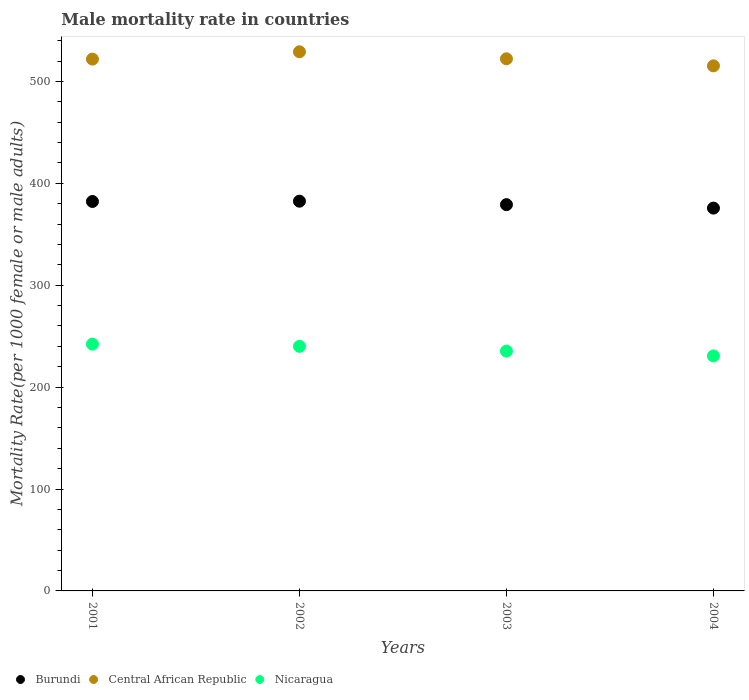What is the male mortality rate in Central African Republic in 2002?
Provide a succinct answer. 529.06. Across all years, what is the maximum male mortality rate in Central African Republic?
Provide a succinct answer. 529.06. Across all years, what is the minimum male mortality rate in Nicaragua?
Make the answer very short. 230.63. In which year was the male mortality rate in Central African Republic maximum?
Your response must be concise. 2002. What is the total male mortality rate in Burundi in the graph?
Offer a terse response. 1519.32. What is the difference between the male mortality rate in Burundi in 2002 and that in 2003?
Ensure brevity in your answer.  3.39. What is the difference between the male mortality rate in Burundi in 2004 and the male mortality rate in Central African Republic in 2001?
Offer a terse response. -146.2. What is the average male mortality rate in Burundi per year?
Your answer should be compact. 379.83. In the year 2001, what is the difference between the male mortality rate in Central African Republic and male mortality rate in Nicaragua?
Your response must be concise. 279.72. In how many years, is the male mortality rate in Central African Republic greater than 160?
Give a very brief answer. 4. What is the ratio of the male mortality rate in Central African Republic in 2001 to that in 2002?
Offer a terse response. 0.99. Is the male mortality rate in Central African Republic in 2002 less than that in 2003?
Make the answer very short. No. What is the difference between the highest and the second highest male mortality rate in Nicaragua?
Your response must be concise. 2.12. What is the difference between the highest and the lowest male mortality rate in Nicaragua?
Your response must be concise. 11.51. In how many years, is the male mortality rate in Burundi greater than the average male mortality rate in Burundi taken over all years?
Your answer should be compact. 2. Is the sum of the male mortality rate in Nicaragua in 2003 and 2004 greater than the maximum male mortality rate in Burundi across all years?
Your answer should be very brief. Yes. Is the male mortality rate in Central African Republic strictly greater than the male mortality rate in Burundi over the years?
Keep it short and to the point. Yes. Is the male mortality rate in Nicaragua strictly less than the male mortality rate in Burundi over the years?
Offer a very short reply. Yes. How many years are there in the graph?
Provide a short and direct response. 4. Does the graph contain grids?
Make the answer very short. No. What is the title of the graph?
Give a very brief answer. Male mortality rate in countries. Does "Senegal" appear as one of the legend labels in the graph?
Provide a succinct answer. No. What is the label or title of the Y-axis?
Provide a short and direct response. Mortality Rate(per 1000 female or male adults). What is the Mortality Rate(per 1000 female or male adults) of Burundi in 2001?
Provide a short and direct response. 382.16. What is the Mortality Rate(per 1000 female or male adults) in Central African Republic in 2001?
Keep it short and to the point. 521.86. What is the Mortality Rate(per 1000 female or male adults) of Nicaragua in 2001?
Offer a terse response. 242.14. What is the Mortality Rate(per 1000 female or male adults) in Burundi in 2002?
Ensure brevity in your answer.  382.45. What is the Mortality Rate(per 1000 female or male adults) of Central African Republic in 2002?
Your answer should be compact. 529.06. What is the Mortality Rate(per 1000 female or male adults) of Nicaragua in 2002?
Provide a succinct answer. 240.02. What is the Mortality Rate(per 1000 female or male adults) in Burundi in 2003?
Give a very brief answer. 379.05. What is the Mortality Rate(per 1000 female or male adults) of Central African Republic in 2003?
Your answer should be compact. 522.16. What is the Mortality Rate(per 1000 female or male adults) of Nicaragua in 2003?
Keep it short and to the point. 235.32. What is the Mortality Rate(per 1000 female or male adults) in Burundi in 2004?
Keep it short and to the point. 375.66. What is the Mortality Rate(per 1000 female or male adults) in Central African Republic in 2004?
Provide a succinct answer. 515.26. What is the Mortality Rate(per 1000 female or male adults) of Nicaragua in 2004?
Your answer should be very brief. 230.63. Across all years, what is the maximum Mortality Rate(per 1000 female or male adults) of Burundi?
Your response must be concise. 382.45. Across all years, what is the maximum Mortality Rate(per 1000 female or male adults) in Central African Republic?
Provide a short and direct response. 529.06. Across all years, what is the maximum Mortality Rate(per 1000 female or male adults) of Nicaragua?
Your response must be concise. 242.14. Across all years, what is the minimum Mortality Rate(per 1000 female or male adults) in Burundi?
Ensure brevity in your answer.  375.66. Across all years, what is the minimum Mortality Rate(per 1000 female or male adults) of Central African Republic?
Offer a very short reply. 515.26. Across all years, what is the minimum Mortality Rate(per 1000 female or male adults) in Nicaragua?
Keep it short and to the point. 230.63. What is the total Mortality Rate(per 1000 female or male adults) in Burundi in the graph?
Your response must be concise. 1519.32. What is the total Mortality Rate(per 1000 female or male adults) in Central African Republic in the graph?
Keep it short and to the point. 2088.35. What is the total Mortality Rate(per 1000 female or male adults) of Nicaragua in the graph?
Provide a short and direct response. 948.11. What is the difference between the Mortality Rate(per 1000 female or male adults) in Burundi in 2001 and that in 2002?
Your response must be concise. -0.28. What is the difference between the Mortality Rate(per 1000 female or male adults) in Central African Republic in 2001 and that in 2002?
Offer a terse response. -7.2. What is the difference between the Mortality Rate(per 1000 female or male adults) in Nicaragua in 2001 and that in 2002?
Your response must be concise. 2.12. What is the difference between the Mortality Rate(per 1000 female or male adults) of Burundi in 2001 and that in 2003?
Your answer should be very brief. 3.11. What is the difference between the Mortality Rate(per 1000 female or male adults) in Central African Republic in 2001 and that in 2003?
Give a very brief answer. -0.3. What is the difference between the Mortality Rate(per 1000 female or male adults) of Nicaragua in 2001 and that in 2003?
Keep it short and to the point. 6.82. What is the difference between the Mortality Rate(per 1000 female or male adults) in Burundi in 2001 and that in 2004?
Offer a terse response. 6.5. What is the difference between the Mortality Rate(per 1000 female or male adults) in Central African Republic in 2001 and that in 2004?
Provide a short and direct response. 6.6. What is the difference between the Mortality Rate(per 1000 female or male adults) in Nicaragua in 2001 and that in 2004?
Your answer should be very brief. 11.51. What is the difference between the Mortality Rate(per 1000 female or male adults) in Burundi in 2002 and that in 2003?
Provide a short and direct response. 3.39. What is the difference between the Mortality Rate(per 1000 female or male adults) in Central African Republic in 2002 and that in 2003?
Your response must be concise. 6.9. What is the difference between the Mortality Rate(per 1000 female or male adults) of Nicaragua in 2002 and that in 2003?
Give a very brief answer. 4.69. What is the difference between the Mortality Rate(per 1000 female or male adults) in Burundi in 2002 and that in 2004?
Your answer should be very brief. 6.79. What is the difference between the Mortality Rate(per 1000 female or male adults) in Central African Republic in 2002 and that in 2004?
Keep it short and to the point. 13.8. What is the difference between the Mortality Rate(per 1000 female or male adults) in Nicaragua in 2002 and that in 2004?
Ensure brevity in your answer.  9.39. What is the difference between the Mortality Rate(per 1000 female or male adults) of Burundi in 2003 and that in 2004?
Your answer should be very brief. 3.39. What is the difference between the Mortality Rate(per 1000 female or male adults) of Central African Republic in 2003 and that in 2004?
Your answer should be very brief. 6.9. What is the difference between the Mortality Rate(per 1000 female or male adults) in Nicaragua in 2003 and that in 2004?
Provide a short and direct response. 4.69. What is the difference between the Mortality Rate(per 1000 female or male adults) of Burundi in 2001 and the Mortality Rate(per 1000 female or male adults) of Central African Republic in 2002?
Your answer should be very brief. -146.9. What is the difference between the Mortality Rate(per 1000 female or male adults) of Burundi in 2001 and the Mortality Rate(per 1000 female or male adults) of Nicaragua in 2002?
Give a very brief answer. 142.15. What is the difference between the Mortality Rate(per 1000 female or male adults) in Central African Republic in 2001 and the Mortality Rate(per 1000 female or male adults) in Nicaragua in 2002?
Offer a terse response. 281.85. What is the difference between the Mortality Rate(per 1000 female or male adults) in Burundi in 2001 and the Mortality Rate(per 1000 female or male adults) in Central African Republic in 2003?
Ensure brevity in your answer.  -140. What is the difference between the Mortality Rate(per 1000 female or male adults) in Burundi in 2001 and the Mortality Rate(per 1000 female or male adults) in Nicaragua in 2003?
Offer a terse response. 146.84. What is the difference between the Mortality Rate(per 1000 female or male adults) of Central African Republic in 2001 and the Mortality Rate(per 1000 female or male adults) of Nicaragua in 2003?
Make the answer very short. 286.54. What is the difference between the Mortality Rate(per 1000 female or male adults) of Burundi in 2001 and the Mortality Rate(per 1000 female or male adults) of Central African Republic in 2004?
Ensure brevity in your answer.  -133.1. What is the difference between the Mortality Rate(per 1000 female or male adults) of Burundi in 2001 and the Mortality Rate(per 1000 female or male adults) of Nicaragua in 2004?
Your response must be concise. 151.53. What is the difference between the Mortality Rate(per 1000 female or male adults) of Central African Republic in 2001 and the Mortality Rate(per 1000 female or male adults) of Nicaragua in 2004?
Make the answer very short. 291.23. What is the difference between the Mortality Rate(per 1000 female or male adults) in Burundi in 2002 and the Mortality Rate(per 1000 female or male adults) in Central African Republic in 2003?
Keep it short and to the point. -139.72. What is the difference between the Mortality Rate(per 1000 female or male adults) in Burundi in 2002 and the Mortality Rate(per 1000 female or male adults) in Nicaragua in 2003?
Your response must be concise. 147.12. What is the difference between the Mortality Rate(per 1000 female or male adults) in Central African Republic in 2002 and the Mortality Rate(per 1000 female or male adults) in Nicaragua in 2003?
Your response must be concise. 293.74. What is the difference between the Mortality Rate(per 1000 female or male adults) of Burundi in 2002 and the Mortality Rate(per 1000 female or male adults) of Central African Republic in 2004?
Make the answer very short. -132.82. What is the difference between the Mortality Rate(per 1000 female or male adults) in Burundi in 2002 and the Mortality Rate(per 1000 female or male adults) in Nicaragua in 2004?
Offer a very short reply. 151.82. What is the difference between the Mortality Rate(per 1000 female or male adults) in Central African Republic in 2002 and the Mortality Rate(per 1000 female or male adults) in Nicaragua in 2004?
Make the answer very short. 298.43. What is the difference between the Mortality Rate(per 1000 female or male adults) of Burundi in 2003 and the Mortality Rate(per 1000 female or male adults) of Central African Republic in 2004?
Your response must be concise. -136.21. What is the difference between the Mortality Rate(per 1000 female or male adults) of Burundi in 2003 and the Mortality Rate(per 1000 female or male adults) of Nicaragua in 2004?
Keep it short and to the point. 148.42. What is the difference between the Mortality Rate(per 1000 female or male adults) of Central African Republic in 2003 and the Mortality Rate(per 1000 female or male adults) of Nicaragua in 2004?
Your answer should be very brief. 291.53. What is the average Mortality Rate(per 1000 female or male adults) in Burundi per year?
Offer a terse response. 379.83. What is the average Mortality Rate(per 1000 female or male adults) in Central African Republic per year?
Offer a terse response. 522.09. What is the average Mortality Rate(per 1000 female or male adults) of Nicaragua per year?
Give a very brief answer. 237.03. In the year 2001, what is the difference between the Mortality Rate(per 1000 female or male adults) of Burundi and Mortality Rate(per 1000 female or male adults) of Central African Republic?
Offer a very short reply. -139.7. In the year 2001, what is the difference between the Mortality Rate(per 1000 female or male adults) of Burundi and Mortality Rate(per 1000 female or male adults) of Nicaragua?
Your answer should be very brief. 140.02. In the year 2001, what is the difference between the Mortality Rate(per 1000 female or male adults) in Central African Republic and Mortality Rate(per 1000 female or male adults) in Nicaragua?
Offer a very short reply. 279.72. In the year 2002, what is the difference between the Mortality Rate(per 1000 female or male adults) in Burundi and Mortality Rate(per 1000 female or male adults) in Central African Republic?
Make the answer very short. -146.62. In the year 2002, what is the difference between the Mortality Rate(per 1000 female or male adults) of Burundi and Mortality Rate(per 1000 female or male adults) of Nicaragua?
Your answer should be compact. 142.43. In the year 2002, what is the difference between the Mortality Rate(per 1000 female or male adults) of Central African Republic and Mortality Rate(per 1000 female or male adults) of Nicaragua?
Provide a succinct answer. 289.05. In the year 2003, what is the difference between the Mortality Rate(per 1000 female or male adults) of Burundi and Mortality Rate(per 1000 female or male adults) of Central African Republic?
Provide a short and direct response. -143.11. In the year 2003, what is the difference between the Mortality Rate(per 1000 female or male adults) in Burundi and Mortality Rate(per 1000 female or male adults) in Nicaragua?
Provide a succinct answer. 143.73. In the year 2003, what is the difference between the Mortality Rate(per 1000 female or male adults) of Central African Republic and Mortality Rate(per 1000 female or male adults) of Nicaragua?
Provide a short and direct response. 286.84. In the year 2004, what is the difference between the Mortality Rate(per 1000 female or male adults) of Burundi and Mortality Rate(per 1000 female or male adults) of Central African Republic?
Give a very brief answer. -139.6. In the year 2004, what is the difference between the Mortality Rate(per 1000 female or male adults) of Burundi and Mortality Rate(per 1000 female or male adults) of Nicaragua?
Your response must be concise. 145.03. In the year 2004, what is the difference between the Mortality Rate(per 1000 female or male adults) in Central African Republic and Mortality Rate(per 1000 female or male adults) in Nicaragua?
Provide a short and direct response. 284.63. What is the ratio of the Mortality Rate(per 1000 female or male adults) in Central African Republic in 2001 to that in 2002?
Your answer should be very brief. 0.99. What is the ratio of the Mortality Rate(per 1000 female or male adults) of Nicaragua in 2001 to that in 2002?
Your answer should be very brief. 1.01. What is the ratio of the Mortality Rate(per 1000 female or male adults) in Burundi in 2001 to that in 2003?
Make the answer very short. 1.01. What is the ratio of the Mortality Rate(per 1000 female or male adults) of Central African Republic in 2001 to that in 2003?
Your answer should be very brief. 1. What is the ratio of the Mortality Rate(per 1000 female or male adults) in Burundi in 2001 to that in 2004?
Give a very brief answer. 1.02. What is the ratio of the Mortality Rate(per 1000 female or male adults) in Central African Republic in 2001 to that in 2004?
Give a very brief answer. 1.01. What is the ratio of the Mortality Rate(per 1000 female or male adults) of Nicaragua in 2001 to that in 2004?
Make the answer very short. 1.05. What is the ratio of the Mortality Rate(per 1000 female or male adults) in Central African Republic in 2002 to that in 2003?
Give a very brief answer. 1.01. What is the ratio of the Mortality Rate(per 1000 female or male adults) in Nicaragua in 2002 to that in 2003?
Provide a short and direct response. 1.02. What is the ratio of the Mortality Rate(per 1000 female or male adults) in Burundi in 2002 to that in 2004?
Make the answer very short. 1.02. What is the ratio of the Mortality Rate(per 1000 female or male adults) of Central African Republic in 2002 to that in 2004?
Ensure brevity in your answer.  1.03. What is the ratio of the Mortality Rate(per 1000 female or male adults) of Nicaragua in 2002 to that in 2004?
Provide a short and direct response. 1.04. What is the ratio of the Mortality Rate(per 1000 female or male adults) of Burundi in 2003 to that in 2004?
Provide a short and direct response. 1.01. What is the ratio of the Mortality Rate(per 1000 female or male adults) in Central African Republic in 2003 to that in 2004?
Your response must be concise. 1.01. What is the ratio of the Mortality Rate(per 1000 female or male adults) of Nicaragua in 2003 to that in 2004?
Your answer should be compact. 1.02. What is the difference between the highest and the second highest Mortality Rate(per 1000 female or male adults) in Burundi?
Offer a very short reply. 0.28. What is the difference between the highest and the second highest Mortality Rate(per 1000 female or male adults) of Central African Republic?
Your response must be concise. 6.9. What is the difference between the highest and the second highest Mortality Rate(per 1000 female or male adults) in Nicaragua?
Your response must be concise. 2.12. What is the difference between the highest and the lowest Mortality Rate(per 1000 female or male adults) of Burundi?
Your answer should be compact. 6.79. What is the difference between the highest and the lowest Mortality Rate(per 1000 female or male adults) of Central African Republic?
Make the answer very short. 13.8. What is the difference between the highest and the lowest Mortality Rate(per 1000 female or male adults) in Nicaragua?
Offer a very short reply. 11.51. 